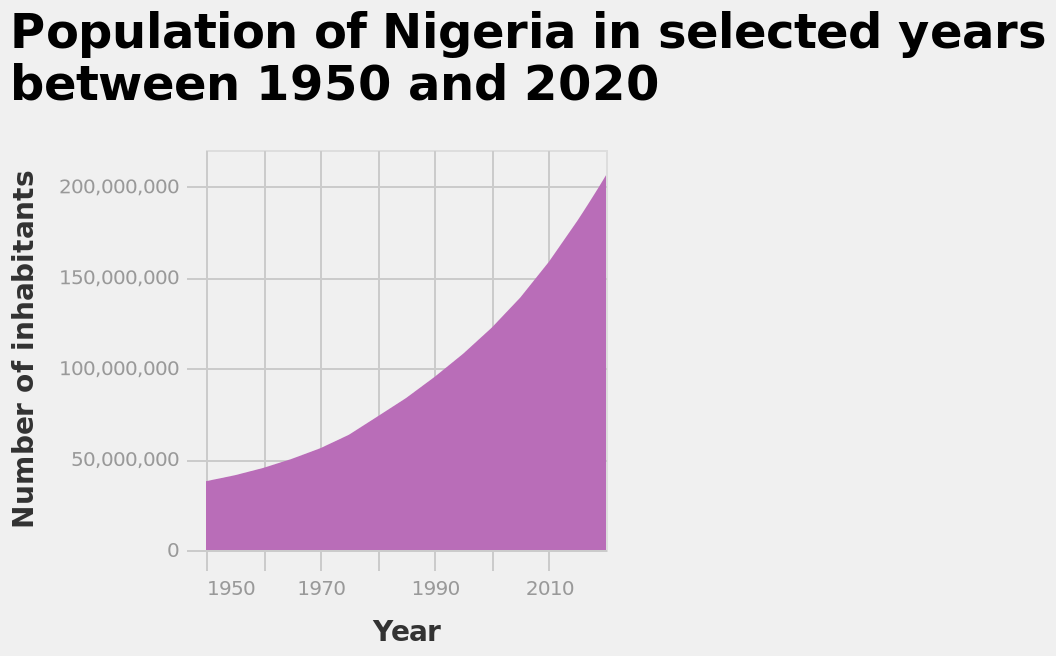<image>
What is the range of years shown on the x-axis? The range of years shown on the x-axis is from 1950 to 2020. What data is being represented by the area chart? The area chart represents the population of Nigeria in selected years between 1950 and 2020. What was the population of Nigeria in 1950?  The population of Nigeria in 1950 was below 50000. What was the population trend in Nigeria from 1950 onwards? There was a slight increase in the population of Nigeria as the years went on. What is the main focus of the area chart? The main focus of the area chart is the population of Nigeria in selected years. please enumerates aspects of the construction of the chart Here a area chart is labeled Population of Nigeria in selected years between 1950 and 2020. The y-axis shows Number of inhabitants while the x-axis plots Year. 